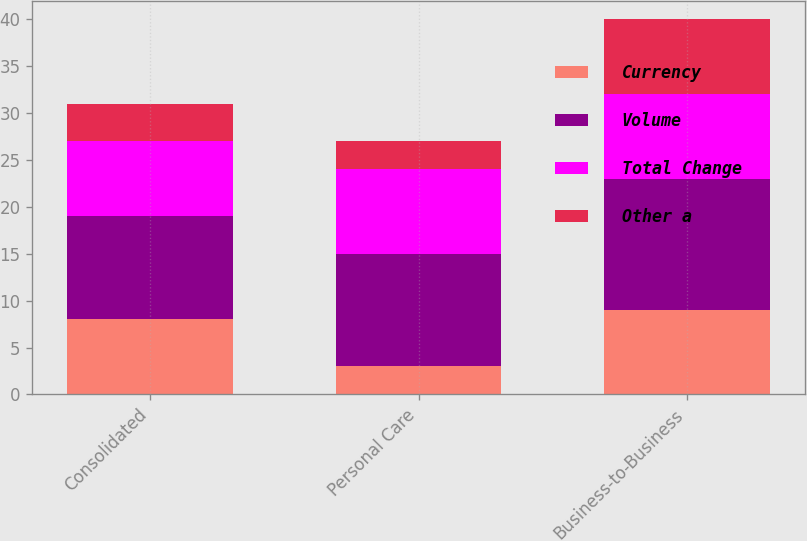Convert chart to OTSL. <chart><loc_0><loc_0><loc_500><loc_500><stacked_bar_chart><ecel><fcel>Consolidated<fcel>Personal Care<fcel>Business-to-Business<nl><fcel>Currency<fcel>8<fcel>3<fcel>9<nl><fcel>Volume<fcel>11<fcel>12<fcel>14<nl><fcel>Total Change<fcel>8<fcel>9<fcel>9<nl><fcel>Other a<fcel>4<fcel>3<fcel>8<nl></chart> 